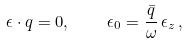Convert formula to latex. <formula><loc_0><loc_0><loc_500><loc_500>\epsilon \cdot q = 0 , \quad \epsilon _ { 0 } = \frac { \bar { q } } { \omega } \, \epsilon _ { z } \, ,</formula> 